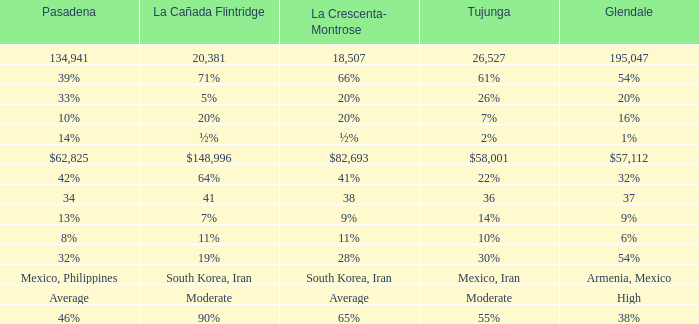When Pasadena is at 10%, what is La Crescenta-Montrose? 20%. 